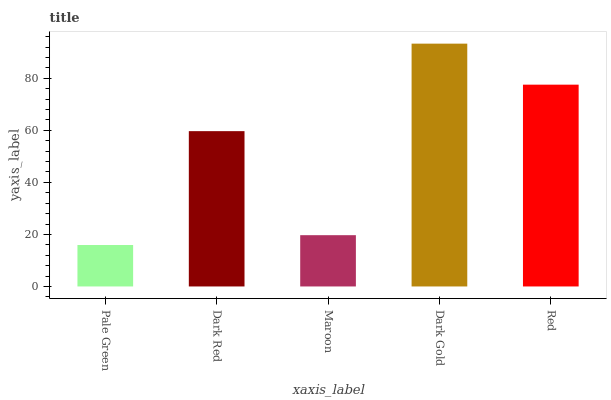Is Pale Green the minimum?
Answer yes or no. Yes. Is Dark Gold the maximum?
Answer yes or no. Yes. Is Dark Red the minimum?
Answer yes or no. No. Is Dark Red the maximum?
Answer yes or no. No. Is Dark Red greater than Pale Green?
Answer yes or no. Yes. Is Pale Green less than Dark Red?
Answer yes or no. Yes. Is Pale Green greater than Dark Red?
Answer yes or no. No. Is Dark Red less than Pale Green?
Answer yes or no. No. Is Dark Red the high median?
Answer yes or no. Yes. Is Dark Red the low median?
Answer yes or no. Yes. Is Dark Gold the high median?
Answer yes or no. No. Is Red the low median?
Answer yes or no. No. 